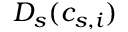Convert formula to latex. <formula><loc_0><loc_0><loc_500><loc_500>D _ { s } { ( c _ { s , i } ) }</formula> 